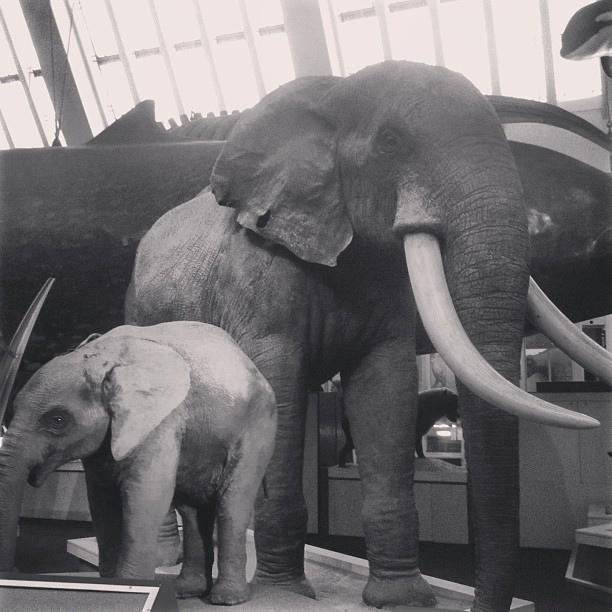Can the elephants hear?
Keep it brief. Yes. How many tusks are in this picture?
Be succinct. 2. Are the elephants animated?
Short answer required. No. Is the younger elephant in the front or back?
Answer briefly. Front. 